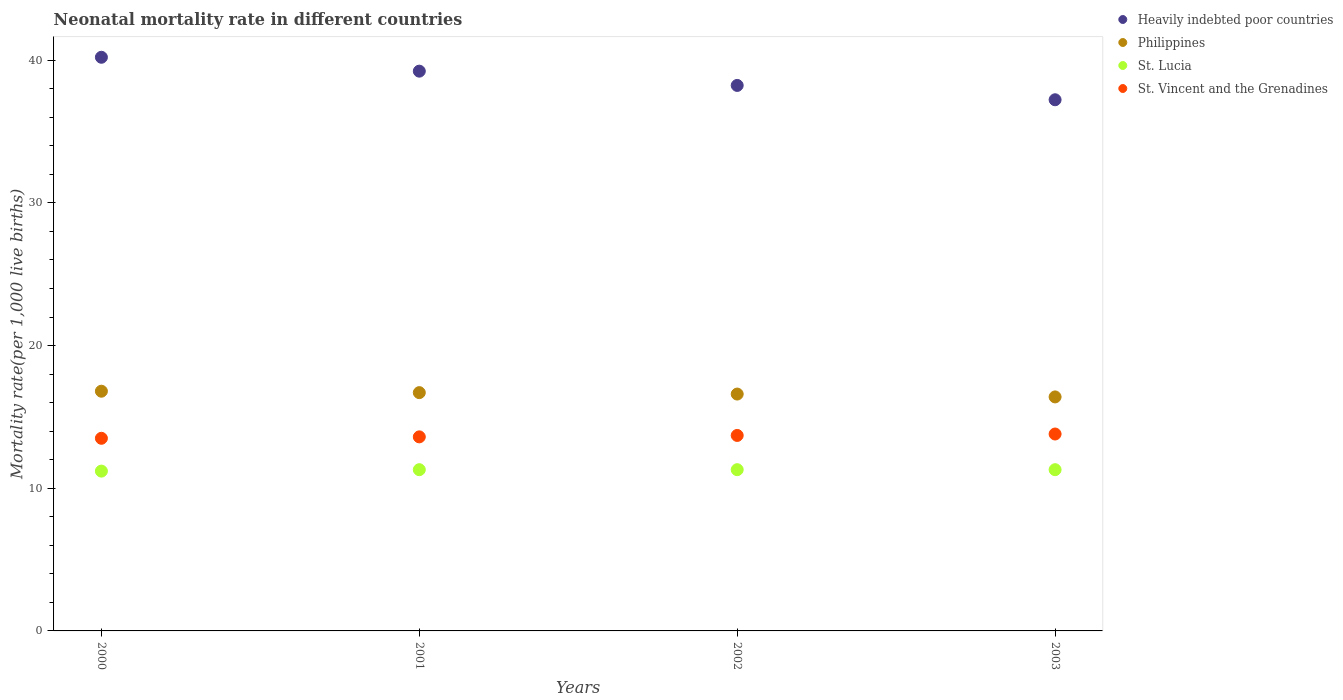How many different coloured dotlines are there?
Offer a very short reply. 4. Across all years, what is the maximum neonatal mortality rate in Philippines?
Your answer should be very brief. 16.8. Across all years, what is the minimum neonatal mortality rate in Philippines?
Give a very brief answer. 16.4. In which year was the neonatal mortality rate in Philippines maximum?
Offer a very short reply. 2000. In which year was the neonatal mortality rate in St. Lucia minimum?
Your answer should be very brief. 2000. What is the total neonatal mortality rate in St. Vincent and the Grenadines in the graph?
Keep it short and to the point. 54.6. What is the difference between the neonatal mortality rate in Philippines in 2000 and that in 2002?
Ensure brevity in your answer.  0.2. What is the difference between the neonatal mortality rate in St. Vincent and the Grenadines in 2002 and the neonatal mortality rate in Heavily indebted poor countries in 2000?
Offer a very short reply. -26.5. What is the average neonatal mortality rate in Philippines per year?
Provide a succinct answer. 16.62. In the year 2001, what is the difference between the neonatal mortality rate in Heavily indebted poor countries and neonatal mortality rate in St. Vincent and the Grenadines?
Give a very brief answer. 25.63. What is the ratio of the neonatal mortality rate in St. Vincent and the Grenadines in 2001 to that in 2003?
Keep it short and to the point. 0.99. What is the difference between the highest and the second highest neonatal mortality rate in Philippines?
Ensure brevity in your answer.  0.1. What is the difference between the highest and the lowest neonatal mortality rate in Philippines?
Offer a very short reply. 0.4. How many dotlines are there?
Provide a succinct answer. 4. How many years are there in the graph?
Your answer should be very brief. 4. What is the difference between two consecutive major ticks on the Y-axis?
Give a very brief answer. 10. Are the values on the major ticks of Y-axis written in scientific E-notation?
Offer a terse response. No. Does the graph contain any zero values?
Provide a short and direct response. No. Where does the legend appear in the graph?
Offer a terse response. Top right. How are the legend labels stacked?
Your response must be concise. Vertical. What is the title of the graph?
Make the answer very short. Neonatal mortality rate in different countries. What is the label or title of the X-axis?
Provide a succinct answer. Years. What is the label or title of the Y-axis?
Provide a succinct answer. Mortality rate(per 1,0 live births). What is the Mortality rate(per 1,000 live births) in Heavily indebted poor countries in 2000?
Ensure brevity in your answer.  40.2. What is the Mortality rate(per 1,000 live births) of St. Lucia in 2000?
Your answer should be compact. 11.2. What is the Mortality rate(per 1,000 live births) of St. Vincent and the Grenadines in 2000?
Provide a succinct answer. 13.5. What is the Mortality rate(per 1,000 live births) of Heavily indebted poor countries in 2001?
Provide a short and direct response. 39.23. What is the Mortality rate(per 1,000 live births) in Philippines in 2001?
Ensure brevity in your answer.  16.7. What is the Mortality rate(per 1,000 live births) in St. Vincent and the Grenadines in 2001?
Your response must be concise. 13.6. What is the Mortality rate(per 1,000 live births) of Heavily indebted poor countries in 2002?
Your answer should be compact. 38.23. What is the Mortality rate(per 1,000 live births) in Heavily indebted poor countries in 2003?
Give a very brief answer. 37.23. What is the Mortality rate(per 1,000 live births) in Philippines in 2003?
Ensure brevity in your answer.  16.4. What is the Mortality rate(per 1,000 live births) in St. Lucia in 2003?
Offer a very short reply. 11.3. Across all years, what is the maximum Mortality rate(per 1,000 live births) of Heavily indebted poor countries?
Provide a succinct answer. 40.2. Across all years, what is the maximum Mortality rate(per 1,000 live births) of St. Lucia?
Provide a short and direct response. 11.3. Across all years, what is the maximum Mortality rate(per 1,000 live births) in St. Vincent and the Grenadines?
Offer a terse response. 13.8. Across all years, what is the minimum Mortality rate(per 1,000 live births) in Heavily indebted poor countries?
Your response must be concise. 37.23. Across all years, what is the minimum Mortality rate(per 1,000 live births) in St. Lucia?
Ensure brevity in your answer.  11.2. What is the total Mortality rate(per 1,000 live births) in Heavily indebted poor countries in the graph?
Ensure brevity in your answer.  154.89. What is the total Mortality rate(per 1,000 live births) of Philippines in the graph?
Your answer should be very brief. 66.5. What is the total Mortality rate(per 1,000 live births) in St. Lucia in the graph?
Ensure brevity in your answer.  45.1. What is the total Mortality rate(per 1,000 live births) in St. Vincent and the Grenadines in the graph?
Provide a short and direct response. 54.6. What is the difference between the Mortality rate(per 1,000 live births) in Heavily indebted poor countries in 2000 and that in 2001?
Provide a succinct answer. 0.97. What is the difference between the Mortality rate(per 1,000 live births) in Philippines in 2000 and that in 2001?
Offer a terse response. 0.1. What is the difference between the Mortality rate(per 1,000 live births) of St. Lucia in 2000 and that in 2001?
Your answer should be very brief. -0.1. What is the difference between the Mortality rate(per 1,000 live births) of St. Vincent and the Grenadines in 2000 and that in 2001?
Your answer should be compact. -0.1. What is the difference between the Mortality rate(per 1,000 live births) of Heavily indebted poor countries in 2000 and that in 2002?
Your answer should be very brief. 1.97. What is the difference between the Mortality rate(per 1,000 live births) of St. Vincent and the Grenadines in 2000 and that in 2002?
Provide a short and direct response. -0.2. What is the difference between the Mortality rate(per 1,000 live births) of Heavily indebted poor countries in 2000 and that in 2003?
Provide a short and direct response. 2.98. What is the difference between the Mortality rate(per 1,000 live births) of Philippines in 2000 and that in 2003?
Offer a very short reply. 0.4. What is the difference between the Mortality rate(per 1,000 live births) of St. Lucia in 2000 and that in 2003?
Keep it short and to the point. -0.1. What is the difference between the Mortality rate(per 1,000 live births) in St. Vincent and the Grenadines in 2000 and that in 2003?
Your response must be concise. -0.3. What is the difference between the Mortality rate(per 1,000 live births) in Heavily indebted poor countries in 2001 and that in 2002?
Your answer should be very brief. 1. What is the difference between the Mortality rate(per 1,000 live births) in Philippines in 2001 and that in 2002?
Offer a terse response. 0.1. What is the difference between the Mortality rate(per 1,000 live births) of St. Lucia in 2001 and that in 2002?
Your answer should be very brief. 0. What is the difference between the Mortality rate(per 1,000 live births) of Heavily indebted poor countries in 2001 and that in 2003?
Your answer should be very brief. 2. What is the difference between the Mortality rate(per 1,000 live births) in St. Lucia in 2001 and that in 2003?
Ensure brevity in your answer.  0. What is the difference between the Mortality rate(per 1,000 live births) in St. Vincent and the Grenadines in 2001 and that in 2003?
Offer a very short reply. -0.2. What is the difference between the Mortality rate(per 1,000 live births) of Heavily indebted poor countries in 2002 and that in 2003?
Ensure brevity in your answer.  1. What is the difference between the Mortality rate(per 1,000 live births) of St. Lucia in 2002 and that in 2003?
Offer a terse response. 0. What is the difference between the Mortality rate(per 1,000 live births) in Heavily indebted poor countries in 2000 and the Mortality rate(per 1,000 live births) in Philippines in 2001?
Your answer should be compact. 23.5. What is the difference between the Mortality rate(per 1,000 live births) in Heavily indebted poor countries in 2000 and the Mortality rate(per 1,000 live births) in St. Lucia in 2001?
Your answer should be very brief. 28.9. What is the difference between the Mortality rate(per 1,000 live births) of Heavily indebted poor countries in 2000 and the Mortality rate(per 1,000 live births) of St. Vincent and the Grenadines in 2001?
Make the answer very short. 26.6. What is the difference between the Mortality rate(per 1,000 live births) in St. Lucia in 2000 and the Mortality rate(per 1,000 live births) in St. Vincent and the Grenadines in 2001?
Offer a terse response. -2.4. What is the difference between the Mortality rate(per 1,000 live births) of Heavily indebted poor countries in 2000 and the Mortality rate(per 1,000 live births) of Philippines in 2002?
Offer a terse response. 23.6. What is the difference between the Mortality rate(per 1,000 live births) in Heavily indebted poor countries in 2000 and the Mortality rate(per 1,000 live births) in St. Lucia in 2002?
Your answer should be very brief. 28.9. What is the difference between the Mortality rate(per 1,000 live births) of Heavily indebted poor countries in 2000 and the Mortality rate(per 1,000 live births) of St. Vincent and the Grenadines in 2002?
Your answer should be compact. 26.5. What is the difference between the Mortality rate(per 1,000 live births) in Philippines in 2000 and the Mortality rate(per 1,000 live births) in St. Lucia in 2002?
Offer a very short reply. 5.5. What is the difference between the Mortality rate(per 1,000 live births) in Heavily indebted poor countries in 2000 and the Mortality rate(per 1,000 live births) in Philippines in 2003?
Make the answer very short. 23.8. What is the difference between the Mortality rate(per 1,000 live births) in Heavily indebted poor countries in 2000 and the Mortality rate(per 1,000 live births) in St. Lucia in 2003?
Offer a terse response. 28.9. What is the difference between the Mortality rate(per 1,000 live births) of Heavily indebted poor countries in 2000 and the Mortality rate(per 1,000 live births) of St. Vincent and the Grenadines in 2003?
Ensure brevity in your answer.  26.4. What is the difference between the Mortality rate(per 1,000 live births) in Philippines in 2000 and the Mortality rate(per 1,000 live births) in St. Lucia in 2003?
Offer a terse response. 5.5. What is the difference between the Mortality rate(per 1,000 live births) of Philippines in 2000 and the Mortality rate(per 1,000 live births) of St. Vincent and the Grenadines in 2003?
Provide a short and direct response. 3. What is the difference between the Mortality rate(per 1,000 live births) of St. Lucia in 2000 and the Mortality rate(per 1,000 live births) of St. Vincent and the Grenadines in 2003?
Provide a short and direct response. -2.6. What is the difference between the Mortality rate(per 1,000 live births) in Heavily indebted poor countries in 2001 and the Mortality rate(per 1,000 live births) in Philippines in 2002?
Ensure brevity in your answer.  22.63. What is the difference between the Mortality rate(per 1,000 live births) of Heavily indebted poor countries in 2001 and the Mortality rate(per 1,000 live births) of St. Lucia in 2002?
Ensure brevity in your answer.  27.93. What is the difference between the Mortality rate(per 1,000 live births) of Heavily indebted poor countries in 2001 and the Mortality rate(per 1,000 live births) of St. Vincent and the Grenadines in 2002?
Ensure brevity in your answer.  25.53. What is the difference between the Mortality rate(per 1,000 live births) in Philippines in 2001 and the Mortality rate(per 1,000 live births) in St. Lucia in 2002?
Ensure brevity in your answer.  5.4. What is the difference between the Mortality rate(per 1,000 live births) in St. Lucia in 2001 and the Mortality rate(per 1,000 live births) in St. Vincent and the Grenadines in 2002?
Keep it short and to the point. -2.4. What is the difference between the Mortality rate(per 1,000 live births) of Heavily indebted poor countries in 2001 and the Mortality rate(per 1,000 live births) of Philippines in 2003?
Offer a very short reply. 22.83. What is the difference between the Mortality rate(per 1,000 live births) of Heavily indebted poor countries in 2001 and the Mortality rate(per 1,000 live births) of St. Lucia in 2003?
Ensure brevity in your answer.  27.93. What is the difference between the Mortality rate(per 1,000 live births) of Heavily indebted poor countries in 2001 and the Mortality rate(per 1,000 live births) of St. Vincent and the Grenadines in 2003?
Make the answer very short. 25.43. What is the difference between the Mortality rate(per 1,000 live births) of Philippines in 2001 and the Mortality rate(per 1,000 live births) of St. Lucia in 2003?
Ensure brevity in your answer.  5.4. What is the difference between the Mortality rate(per 1,000 live births) in Philippines in 2001 and the Mortality rate(per 1,000 live births) in St. Vincent and the Grenadines in 2003?
Make the answer very short. 2.9. What is the difference between the Mortality rate(per 1,000 live births) of St. Lucia in 2001 and the Mortality rate(per 1,000 live births) of St. Vincent and the Grenadines in 2003?
Your answer should be compact. -2.5. What is the difference between the Mortality rate(per 1,000 live births) in Heavily indebted poor countries in 2002 and the Mortality rate(per 1,000 live births) in Philippines in 2003?
Your response must be concise. 21.83. What is the difference between the Mortality rate(per 1,000 live births) in Heavily indebted poor countries in 2002 and the Mortality rate(per 1,000 live births) in St. Lucia in 2003?
Your response must be concise. 26.93. What is the difference between the Mortality rate(per 1,000 live births) in Heavily indebted poor countries in 2002 and the Mortality rate(per 1,000 live births) in St. Vincent and the Grenadines in 2003?
Offer a terse response. 24.43. What is the difference between the Mortality rate(per 1,000 live births) in Philippines in 2002 and the Mortality rate(per 1,000 live births) in St. Lucia in 2003?
Your answer should be very brief. 5.3. What is the average Mortality rate(per 1,000 live births) in Heavily indebted poor countries per year?
Your answer should be compact. 38.72. What is the average Mortality rate(per 1,000 live births) in Philippines per year?
Offer a very short reply. 16.62. What is the average Mortality rate(per 1,000 live births) in St. Lucia per year?
Provide a short and direct response. 11.28. What is the average Mortality rate(per 1,000 live births) in St. Vincent and the Grenadines per year?
Keep it short and to the point. 13.65. In the year 2000, what is the difference between the Mortality rate(per 1,000 live births) of Heavily indebted poor countries and Mortality rate(per 1,000 live births) of Philippines?
Provide a succinct answer. 23.4. In the year 2000, what is the difference between the Mortality rate(per 1,000 live births) in Heavily indebted poor countries and Mortality rate(per 1,000 live births) in St. Lucia?
Provide a succinct answer. 29. In the year 2000, what is the difference between the Mortality rate(per 1,000 live births) in Heavily indebted poor countries and Mortality rate(per 1,000 live births) in St. Vincent and the Grenadines?
Provide a short and direct response. 26.7. In the year 2000, what is the difference between the Mortality rate(per 1,000 live births) in Philippines and Mortality rate(per 1,000 live births) in St. Lucia?
Give a very brief answer. 5.6. In the year 2000, what is the difference between the Mortality rate(per 1,000 live births) in St. Lucia and Mortality rate(per 1,000 live births) in St. Vincent and the Grenadines?
Give a very brief answer. -2.3. In the year 2001, what is the difference between the Mortality rate(per 1,000 live births) of Heavily indebted poor countries and Mortality rate(per 1,000 live births) of Philippines?
Offer a terse response. 22.53. In the year 2001, what is the difference between the Mortality rate(per 1,000 live births) of Heavily indebted poor countries and Mortality rate(per 1,000 live births) of St. Lucia?
Provide a succinct answer. 27.93. In the year 2001, what is the difference between the Mortality rate(per 1,000 live births) of Heavily indebted poor countries and Mortality rate(per 1,000 live births) of St. Vincent and the Grenadines?
Ensure brevity in your answer.  25.63. In the year 2002, what is the difference between the Mortality rate(per 1,000 live births) of Heavily indebted poor countries and Mortality rate(per 1,000 live births) of Philippines?
Ensure brevity in your answer.  21.63. In the year 2002, what is the difference between the Mortality rate(per 1,000 live births) in Heavily indebted poor countries and Mortality rate(per 1,000 live births) in St. Lucia?
Make the answer very short. 26.93. In the year 2002, what is the difference between the Mortality rate(per 1,000 live births) of Heavily indebted poor countries and Mortality rate(per 1,000 live births) of St. Vincent and the Grenadines?
Your answer should be compact. 24.53. In the year 2002, what is the difference between the Mortality rate(per 1,000 live births) of St. Lucia and Mortality rate(per 1,000 live births) of St. Vincent and the Grenadines?
Your answer should be compact. -2.4. In the year 2003, what is the difference between the Mortality rate(per 1,000 live births) of Heavily indebted poor countries and Mortality rate(per 1,000 live births) of Philippines?
Make the answer very short. 20.83. In the year 2003, what is the difference between the Mortality rate(per 1,000 live births) in Heavily indebted poor countries and Mortality rate(per 1,000 live births) in St. Lucia?
Offer a very short reply. 25.93. In the year 2003, what is the difference between the Mortality rate(per 1,000 live births) in Heavily indebted poor countries and Mortality rate(per 1,000 live births) in St. Vincent and the Grenadines?
Ensure brevity in your answer.  23.43. In the year 2003, what is the difference between the Mortality rate(per 1,000 live births) of Philippines and Mortality rate(per 1,000 live births) of St. Lucia?
Keep it short and to the point. 5.1. What is the ratio of the Mortality rate(per 1,000 live births) in Heavily indebted poor countries in 2000 to that in 2001?
Offer a terse response. 1.02. What is the ratio of the Mortality rate(per 1,000 live births) in St. Lucia in 2000 to that in 2001?
Your answer should be compact. 0.99. What is the ratio of the Mortality rate(per 1,000 live births) in St. Vincent and the Grenadines in 2000 to that in 2001?
Offer a very short reply. 0.99. What is the ratio of the Mortality rate(per 1,000 live births) in Heavily indebted poor countries in 2000 to that in 2002?
Offer a very short reply. 1.05. What is the ratio of the Mortality rate(per 1,000 live births) in Philippines in 2000 to that in 2002?
Make the answer very short. 1.01. What is the ratio of the Mortality rate(per 1,000 live births) of St. Lucia in 2000 to that in 2002?
Provide a short and direct response. 0.99. What is the ratio of the Mortality rate(per 1,000 live births) in St. Vincent and the Grenadines in 2000 to that in 2002?
Your answer should be compact. 0.99. What is the ratio of the Mortality rate(per 1,000 live births) of Philippines in 2000 to that in 2003?
Your answer should be very brief. 1.02. What is the ratio of the Mortality rate(per 1,000 live births) in St. Vincent and the Grenadines in 2000 to that in 2003?
Provide a short and direct response. 0.98. What is the ratio of the Mortality rate(per 1,000 live births) of Heavily indebted poor countries in 2001 to that in 2002?
Ensure brevity in your answer.  1.03. What is the ratio of the Mortality rate(per 1,000 live births) of St. Lucia in 2001 to that in 2002?
Keep it short and to the point. 1. What is the ratio of the Mortality rate(per 1,000 live births) of St. Vincent and the Grenadines in 2001 to that in 2002?
Offer a terse response. 0.99. What is the ratio of the Mortality rate(per 1,000 live births) in Heavily indebted poor countries in 2001 to that in 2003?
Provide a succinct answer. 1.05. What is the ratio of the Mortality rate(per 1,000 live births) in Philippines in 2001 to that in 2003?
Ensure brevity in your answer.  1.02. What is the ratio of the Mortality rate(per 1,000 live births) of St. Lucia in 2001 to that in 2003?
Give a very brief answer. 1. What is the ratio of the Mortality rate(per 1,000 live births) of St. Vincent and the Grenadines in 2001 to that in 2003?
Make the answer very short. 0.99. What is the ratio of the Mortality rate(per 1,000 live births) of Philippines in 2002 to that in 2003?
Ensure brevity in your answer.  1.01. What is the ratio of the Mortality rate(per 1,000 live births) of St. Vincent and the Grenadines in 2002 to that in 2003?
Give a very brief answer. 0.99. What is the difference between the highest and the second highest Mortality rate(per 1,000 live births) in Heavily indebted poor countries?
Provide a succinct answer. 0.97. What is the difference between the highest and the second highest Mortality rate(per 1,000 live births) of St. Vincent and the Grenadines?
Ensure brevity in your answer.  0.1. What is the difference between the highest and the lowest Mortality rate(per 1,000 live births) of Heavily indebted poor countries?
Offer a very short reply. 2.98. What is the difference between the highest and the lowest Mortality rate(per 1,000 live births) in St. Lucia?
Your answer should be very brief. 0.1. 